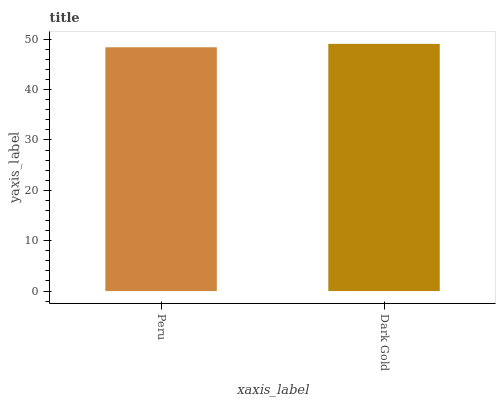Is Peru the minimum?
Answer yes or no. Yes. Is Dark Gold the maximum?
Answer yes or no. Yes. Is Dark Gold the minimum?
Answer yes or no. No. Is Dark Gold greater than Peru?
Answer yes or no. Yes. Is Peru less than Dark Gold?
Answer yes or no. Yes. Is Peru greater than Dark Gold?
Answer yes or no. No. Is Dark Gold less than Peru?
Answer yes or no. No. Is Dark Gold the high median?
Answer yes or no. Yes. Is Peru the low median?
Answer yes or no. Yes. Is Peru the high median?
Answer yes or no. No. Is Dark Gold the low median?
Answer yes or no. No. 